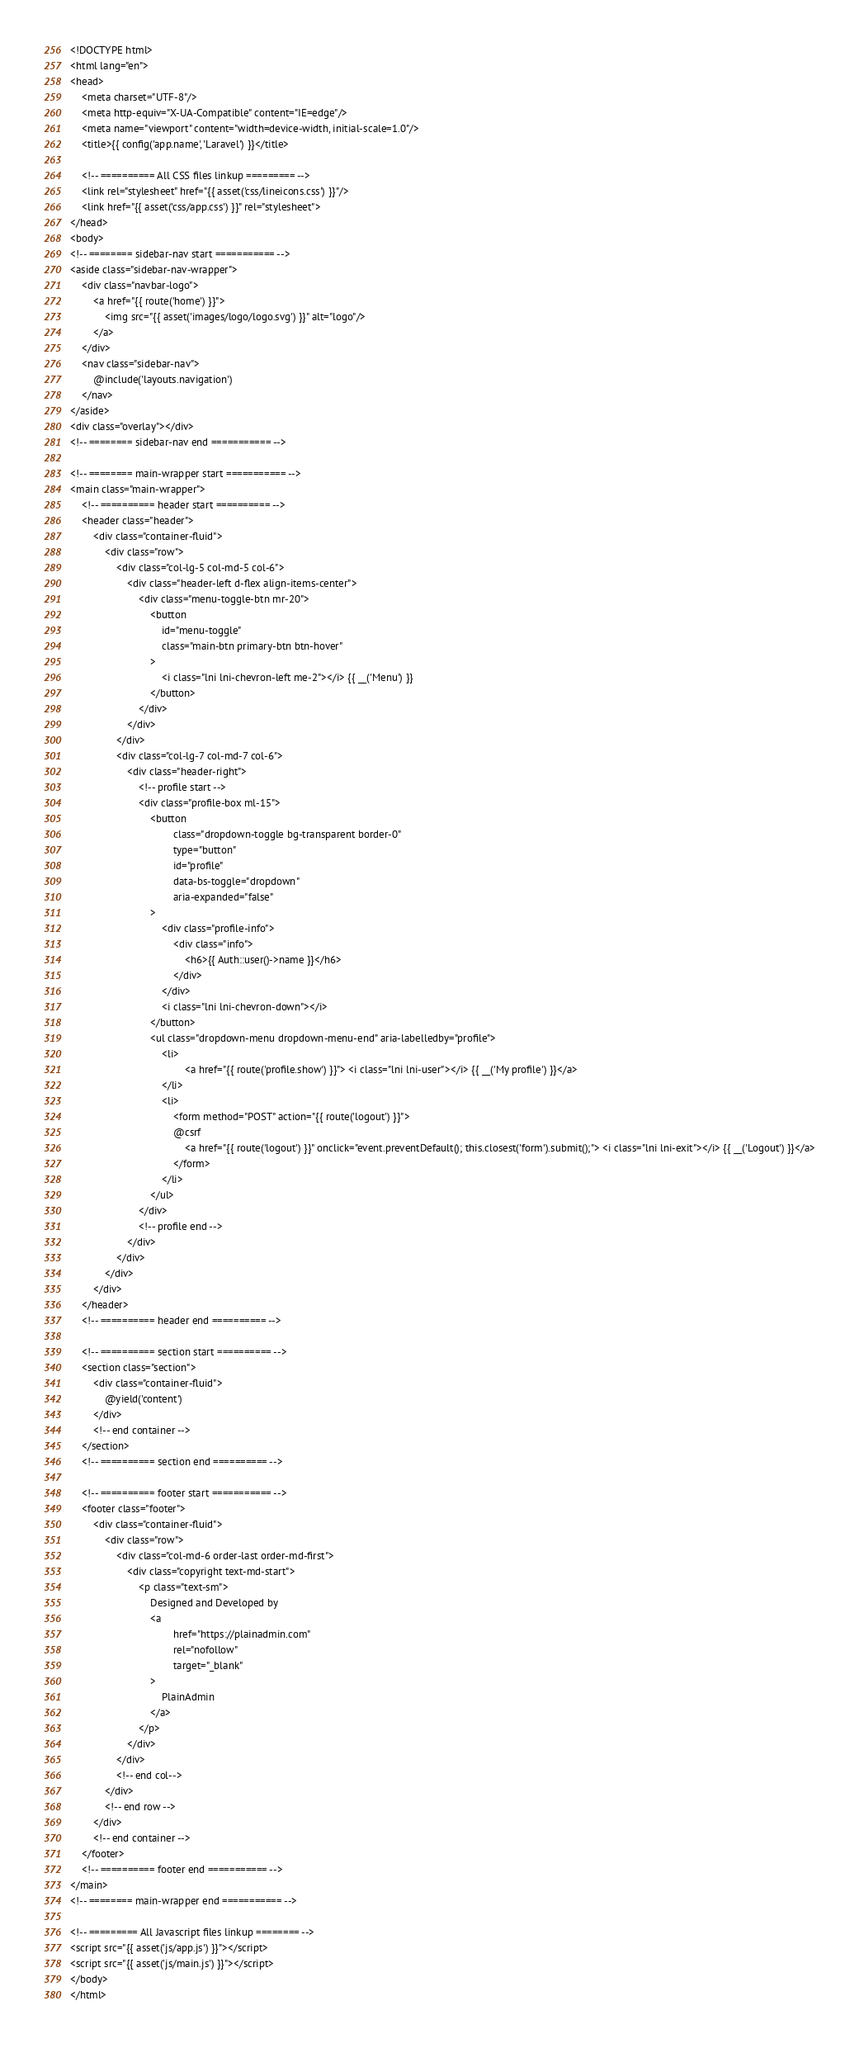<code> <loc_0><loc_0><loc_500><loc_500><_PHP_><!DOCTYPE html>
<html lang="en">
<head>
    <meta charset="UTF-8"/>
    <meta http-equiv="X-UA-Compatible" content="IE=edge"/>
    <meta name="viewport" content="width=device-width, initial-scale=1.0"/>
    <title>{{ config('app.name', 'Laravel') }}</title>

    <!-- ========== All CSS files linkup ========= -->
    <link rel="stylesheet" href="{{ asset('css/lineicons.css') }}"/>
    <link href="{{ asset('css/app.css') }}" rel="stylesheet">
</head>
<body>
<!-- ======== sidebar-nav start =========== -->
<aside class="sidebar-nav-wrapper">
    <div class="navbar-logo">
        <a href="{{ route('home') }}">
            <img src="{{ asset('images/logo/logo.svg') }}" alt="logo"/>
        </a>
    </div>
    <nav class="sidebar-nav">
        @include('layouts.navigation')
    </nav>
</aside>
<div class="overlay"></div>
<!-- ======== sidebar-nav end =========== -->

<!-- ======== main-wrapper start =========== -->
<main class="main-wrapper">
    <!-- ========== header start ========== -->
    <header class="header">
        <div class="container-fluid">
            <div class="row">
                <div class="col-lg-5 col-md-5 col-6">
                    <div class="header-left d-flex align-items-center">
                        <div class="menu-toggle-btn mr-20">
                            <button
                                id="menu-toggle"
                                class="main-btn primary-btn btn-hover"
                            >
                                <i class="lni lni-chevron-left me-2"></i> {{ __('Menu') }}
                            </button>
                        </div>
                    </div>
                </div>
                <div class="col-lg-7 col-md-7 col-6">
                    <div class="header-right">
                        <!-- profile start -->
                        <div class="profile-box ml-15">
                            <button
                                    class="dropdown-toggle bg-transparent border-0"
                                    type="button"
                                    id="profile"
                                    data-bs-toggle="dropdown"
                                    aria-expanded="false"
                            >
                                <div class="profile-info">
                                    <div class="info">
                                        <h6>{{ Auth::user()->name }}</h6>
                                    </div>
                                </div>
                                <i class="lni lni-chevron-down"></i>
                            </button>
                            <ul class="dropdown-menu dropdown-menu-end" aria-labelledby="profile">
                                <li>
                                        <a href="{{ route('profile.show') }}"> <i class="lni lni-user"></i> {{ __('My profile') }}</a>
                                </li>
                                <li>
                                    <form method="POST" action="{{ route('logout') }}">
                                    @csrf
                                        <a href="{{ route('logout') }}" onclick="event.preventDefault(); this.closest('form').submit();"> <i class="lni lni-exit"></i> {{ __('Logout') }}</a>
                                    </form>
                                </li>
                            </ul>
                        </div>
                        <!-- profile end -->
                    </div>
                </div>
            </div>
        </div>
    </header>
    <!-- ========== header end ========== -->

    <!-- ========== section start ========== -->
    <section class="section">
        <div class="container-fluid">
            @yield('content')
        </div>
        <!-- end container -->
    </section>
    <!-- ========== section end ========== -->

    <!-- ========== footer start =========== -->
    <footer class="footer">
        <div class="container-fluid">
            <div class="row">
                <div class="col-md-6 order-last order-md-first">
                    <div class="copyright text-md-start">
                        <p class="text-sm">
                            Designed and Developed by
                            <a
                                    href="https://plainadmin.com"
                                    rel="nofollow"
                                    target="_blank"
                            >
                                PlainAdmin
                            </a>
                        </p>
                    </div>
                </div>
                <!-- end col-->
            </div>
            <!-- end row -->
        </div>
        <!-- end container -->
    </footer>
    <!-- ========== footer end =========== -->
</main>
<!-- ======== main-wrapper end =========== -->

<!-- ========= All Javascript files linkup ======== -->
<script src="{{ asset('js/app.js') }}"></script>
<script src="{{ asset('js/main.js') }}"></script>
</body>
</html>
</code> 